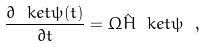Convert formula to latex. <formula><loc_0><loc_0><loc_500><loc_500>\frac { \partial \ k e t { \psi ( t ) } } { \partial t } = \Omega \hat { H } \ k e t { \psi } \ ,</formula> 